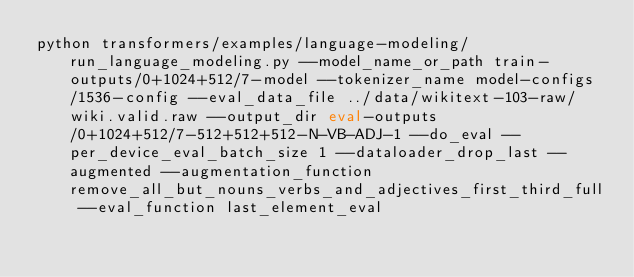Convert code to text. <code><loc_0><loc_0><loc_500><loc_500><_Bash_>python transformers/examples/language-modeling/run_language_modeling.py --model_name_or_path train-outputs/0+1024+512/7-model --tokenizer_name model-configs/1536-config --eval_data_file ../data/wikitext-103-raw/wiki.valid.raw --output_dir eval-outputs/0+1024+512/7-512+512+512-N-VB-ADJ-1 --do_eval --per_device_eval_batch_size 1 --dataloader_drop_last --augmented --augmentation_function remove_all_but_nouns_verbs_and_adjectives_first_third_full --eval_function last_element_eval</code> 